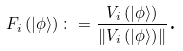Convert formula to latex. <formula><loc_0><loc_0><loc_500><loc_500>F _ { i } \left ( | \phi \rangle \right ) \colon = \frac { V _ { i } \left ( | \phi \rangle \right ) } { \left \| V _ { i } \left ( | \phi \rangle \right ) \right \| } \text {.}</formula> 